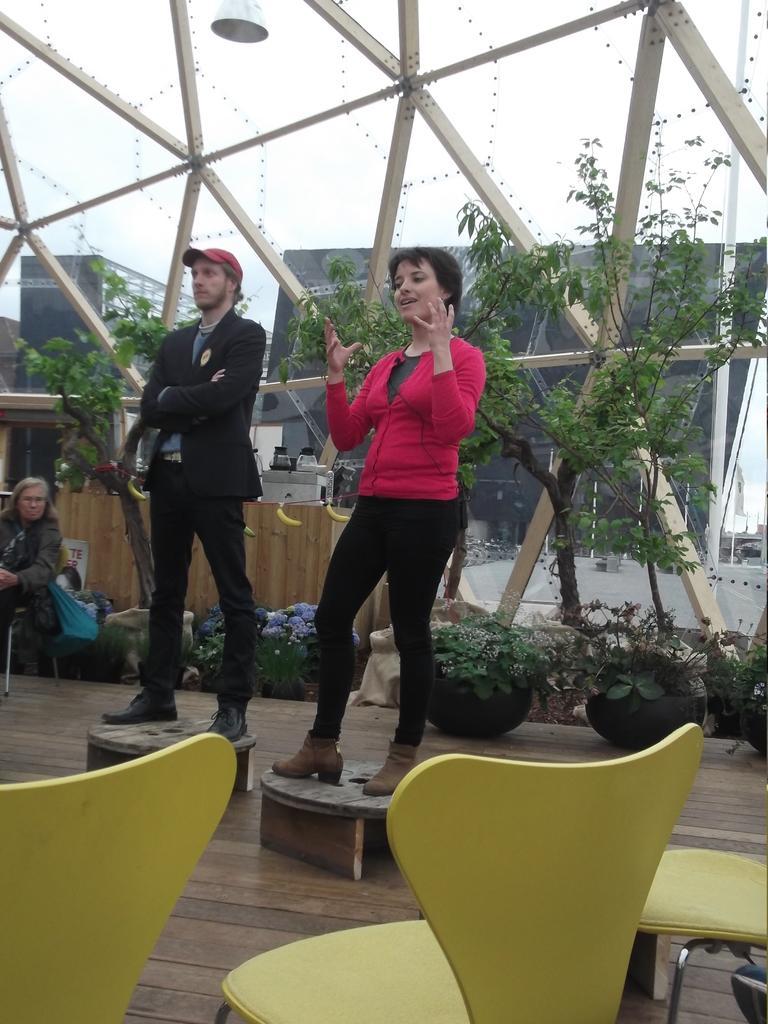How would you summarize this image in a sentence or two? In this image there are chairs, tables, persons, potted plants and trees in the foreground. There are buildings, cupboard in the background. There is a light hanging on roof at the top. 